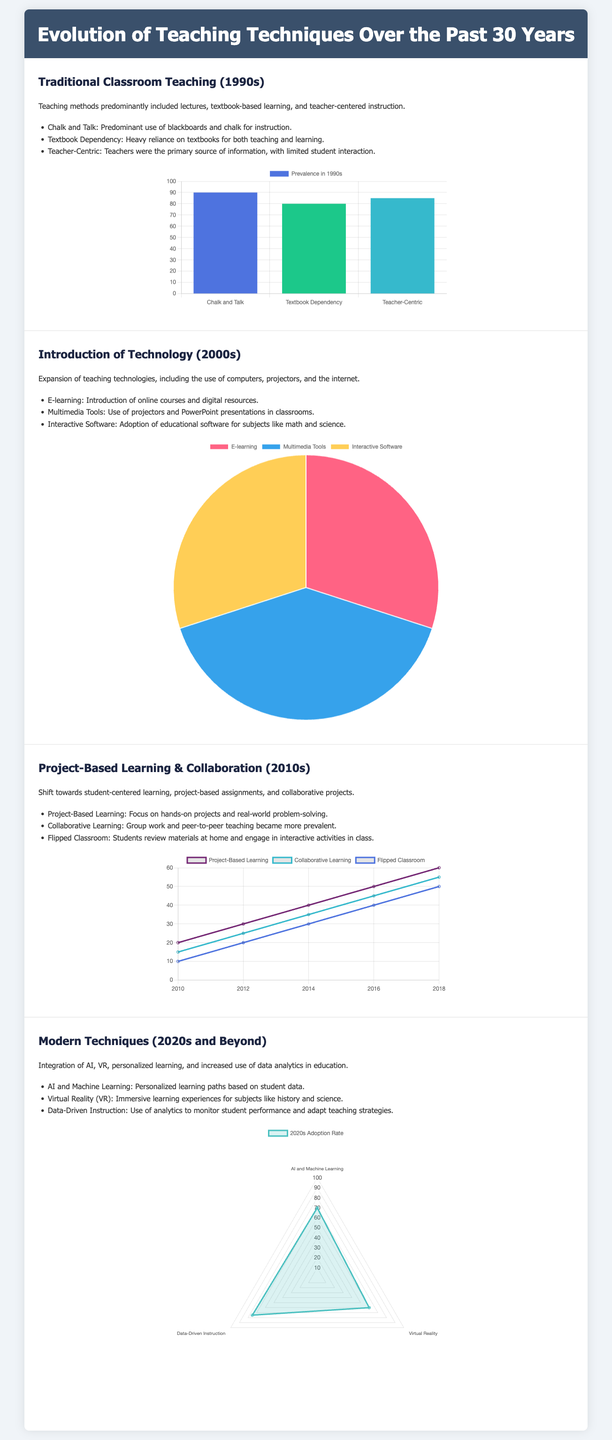what were the main teaching methods in the 1990s? The document lists three main methods: Chalk and Talk, Textbook Dependency, and Teacher-Centric Instruction.
Answer: Chalk and Talk, Textbook Dependency, Teacher-Centric which teaching method had a prevalence of 90 in the 1990s? The chart from the 1990s shows "Chalk and Talk" had a prevalence of 90.
Answer: 90 what is the most prevalent teaching technology introduced in the 2000s? The pie chart indicates Multimedia Tools had the highest percentage at 40.
Answer: Multimedia Tools how did the prevalence of Project-Based Learning change from 2010 to 2018? The line chart shows a consistent increase from 20 in 2010 to 60 in 2018, showing a growth trend.
Answer: Increased by 40 which modern technique had the highest adoption rate in the 2020s? The radar chart indicates that "AI and Machine Learning" had the highest adoption rate at 70.
Answer: 70 what technological tool was first introduced in the 2000s? The document mentions E-learning as one of the first tools introduced during this decade.
Answer: E-learning which teaching technique is characterized by students reviewing materials at home? The document describes the Flipped Classroom as a method where students review materials at home.
Answer: Flipped Classroom what is one of the emerging techniques in the 2020s? The document lists AI and Machine Learning as one of the modern teaching techniques for the 2020s and beyond.
Answer: AI and Machine Learning how does data-driven instruction help teachers? The document states that data-driven instruction allows teachers to monitor student performance and adapt teaching strategies.
Answer: Adapts teaching strategies what was a significant feature of collaborative learning in the 2010s? Collaborative learning is described in the document as involving group work and peer-to-peer teaching.
Answer: Group work and peer-to-peer teaching 